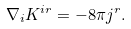Convert formula to latex. <formula><loc_0><loc_0><loc_500><loc_500>\nabla _ { i } K ^ { i r } = - 8 \pi j ^ { r } .</formula> 